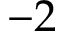<formula> <loc_0><loc_0><loc_500><loc_500>- 2</formula> 